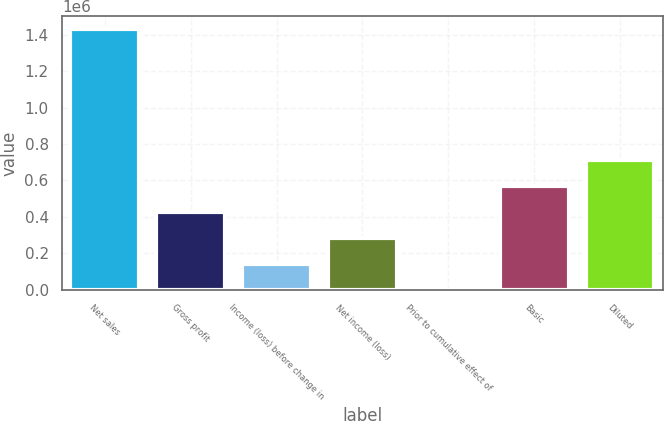Convert chart to OTSL. <chart><loc_0><loc_0><loc_500><loc_500><bar_chart><fcel>Net sales<fcel>Gross profit<fcel>Income (loss) before change in<fcel>Net income (loss)<fcel>Prior to cumulative effect of<fcel>Basic<fcel>Diluted<nl><fcel>1.42861e+06<fcel>428583<fcel>142861<fcel>285722<fcel>0.01<fcel>571444<fcel>714305<nl></chart> 